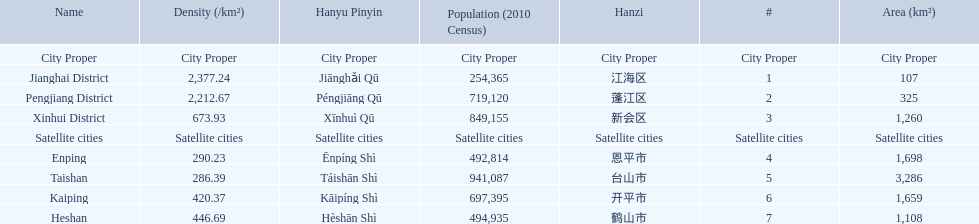What are all of the city proper district names? Jianghai District, Pengjiang District, Xinhui District. Of those districts, what are is the value for their area (km2)? 107, 325, 1,260. Of those area values, which district does the smallest value belong to? Jianghai District. 